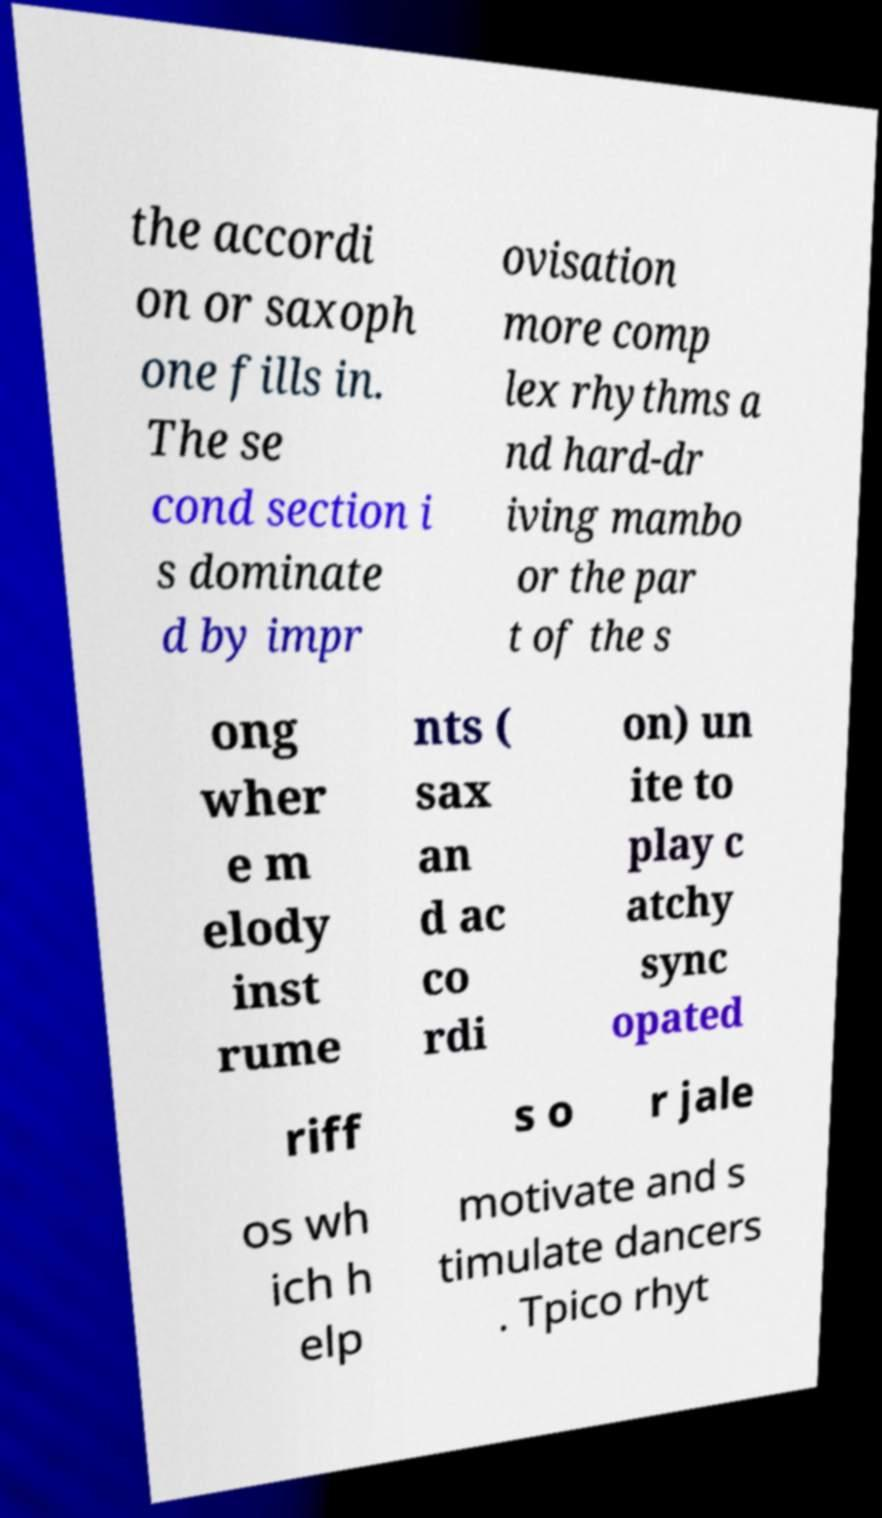Could you extract and type out the text from this image? the accordi on or saxoph one fills in. The se cond section i s dominate d by impr ovisation more comp lex rhythms a nd hard-dr iving mambo or the par t of the s ong wher e m elody inst rume nts ( sax an d ac co rdi on) un ite to play c atchy sync opated riff s o r jale os wh ich h elp motivate and s timulate dancers . Tpico rhyt 